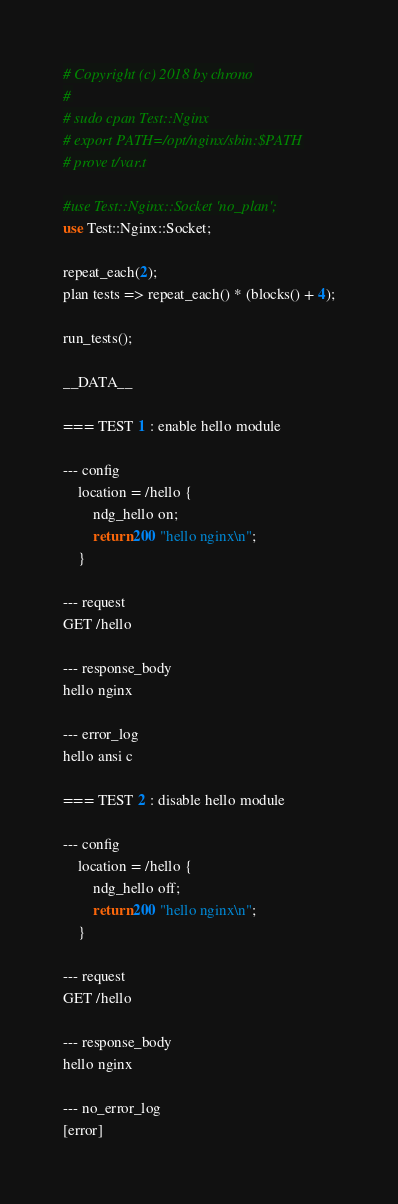Convert code to text. <code><loc_0><loc_0><loc_500><loc_500><_Perl_># Copyright (c) 2018 by chrono
#
# sudo cpan Test::Nginx
# export PATH=/opt/nginx/sbin:$PATH
# prove t/var.t

#use Test::Nginx::Socket 'no_plan';
use Test::Nginx::Socket;

repeat_each(2);
plan tests => repeat_each() * (blocks() + 4);

run_tests();

__DATA__

=== TEST 1 : enable hello module

--- config
    location = /hello {
        ndg_hello on;
        return 200 "hello nginx\n";
    }

--- request
GET /hello

--- response_body
hello nginx

--- error_log
hello ansi c

=== TEST 2 : disable hello module

--- config
    location = /hello {
        ndg_hello off;
        return 200 "hello nginx\n";
    }

--- request
GET /hello

--- response_body
hello nginx

--- no_error_log
[error]

</code> 